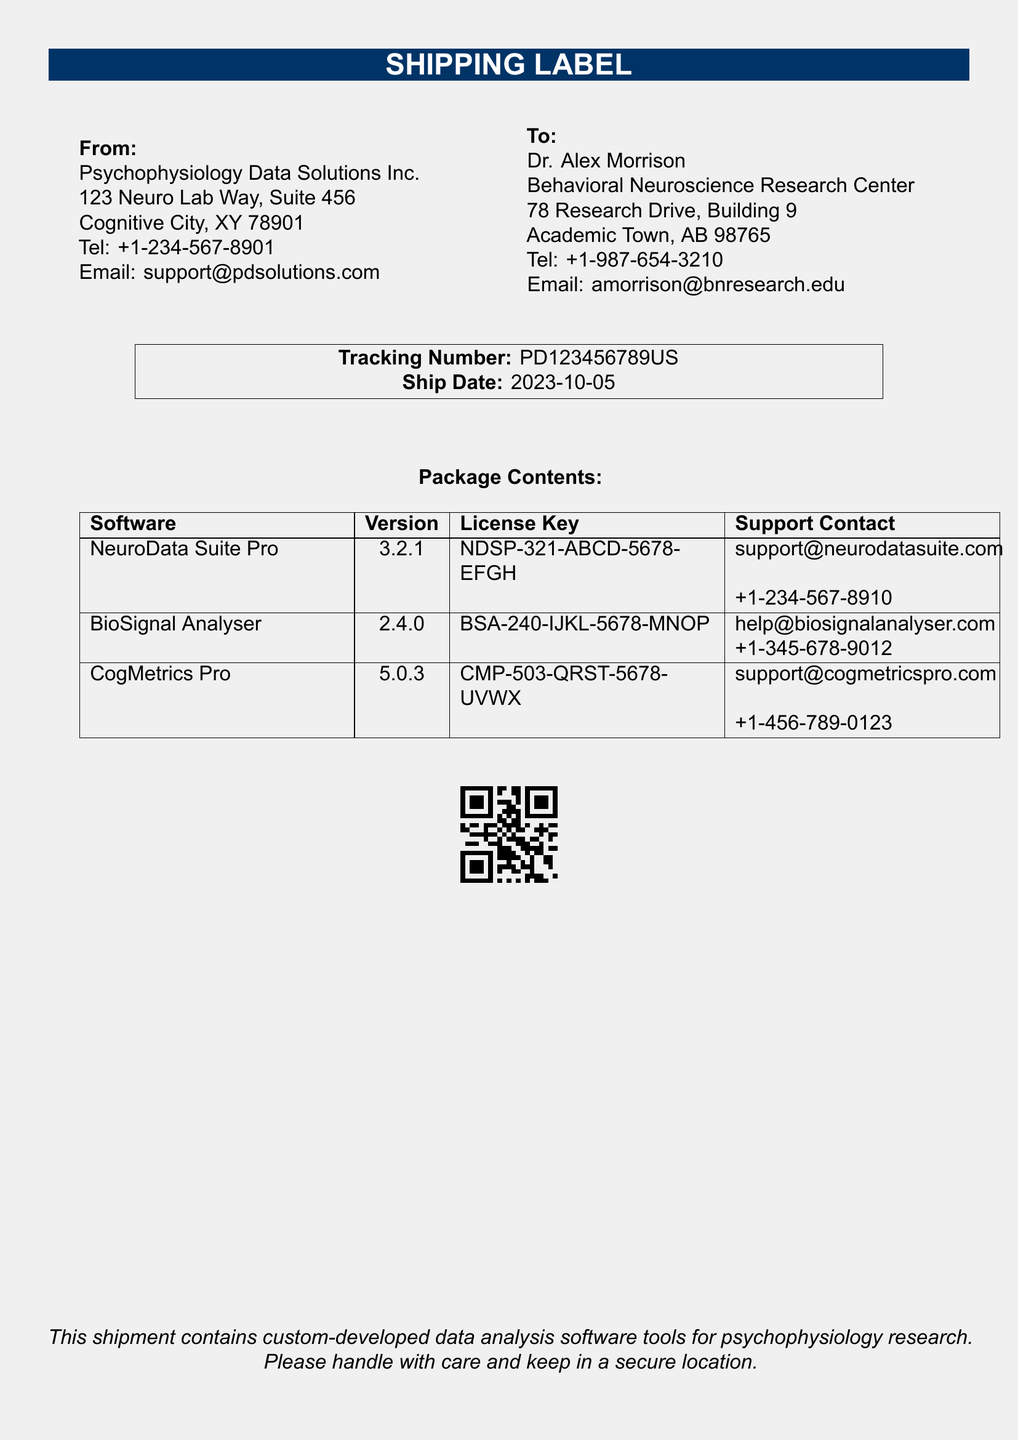What is the name of the sender? The name of the sender is the entity providing the shipment, listed at the top of the document.
Answer: Psychophysiology Data Solutions Inc What is the tracking number? The tracking number provides a unique identifier for the shipment, found in the center section of the document.
Answer: PD123456789US What is the license key for NeuroData Suite Pro? The license key is a unique code assigned to the software, which is included in the package contents.
Answer: NDSP-321-ABCD-5678-EFGH What is the version number of BioSignal Analyser? The version number indicates the specific release of the software, which can be found in the table of package contents.
Answer: 2.4.0 Who is the recipient? The recipient is the person or organization receiving the shipment, identified in the "To" section.
Answer: Dr. Alex Morrison Which software has the highest version number? This question asks for the software with the latest release, requiring comparison of version numbers in the document.
Answer: CogMetrics Pro What is the ship date? The ship date indicates when the shipment was sent, displayed alongside the tracking number.
Answer: 2023-10-05 What is the email for support for CogMetrics Pro? The email provides a means to obtain assistance for specific software, found within the table of contents.
Answer: support@cogmetricspro.com What type of software is included in this shipment? This question seeks to identify the nature of the items being shipped, as described in the final section of the document.
Answer: data analysis software tools for psychophysiology research 